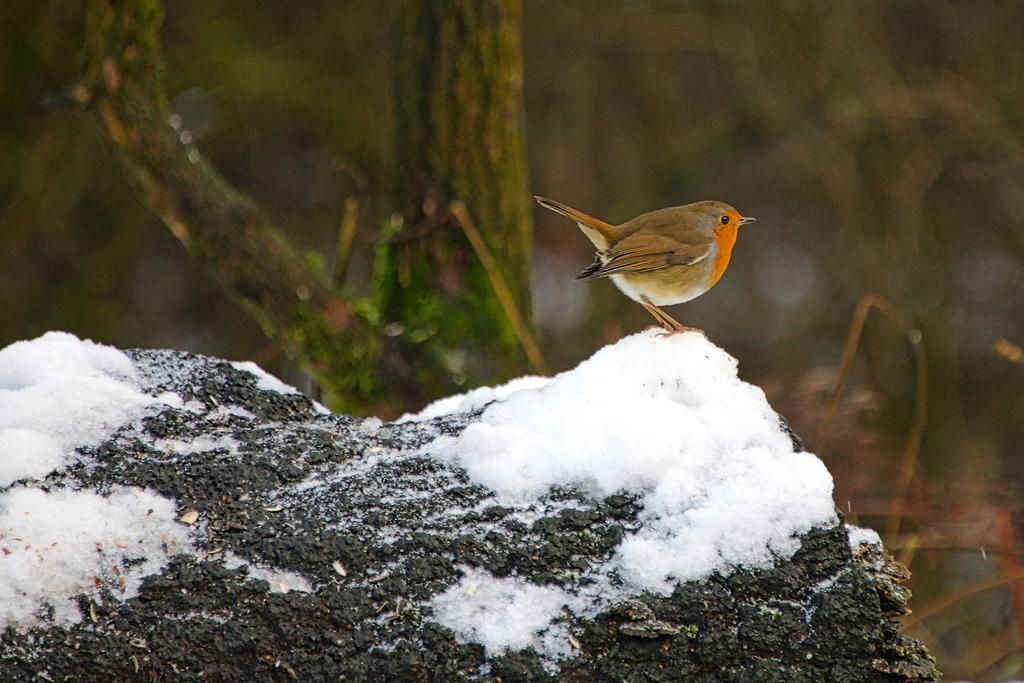What type of animal can be seen in the picture? There is a bird in the picture. Where is the bird located in the image? The bird is standing on a rock. What is covering the rock in the image? There is snow on the rock. What can be seen in the background of the picture? There are trees in the background of the picture. What type of grain is being fed to the bird in the image? There is no grain present in the image, and the bird is not being fed anything. 